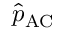<formula> <loc_0><loc_0><loc_500><loc_500>\hat { p } _ { A C }</formula> 